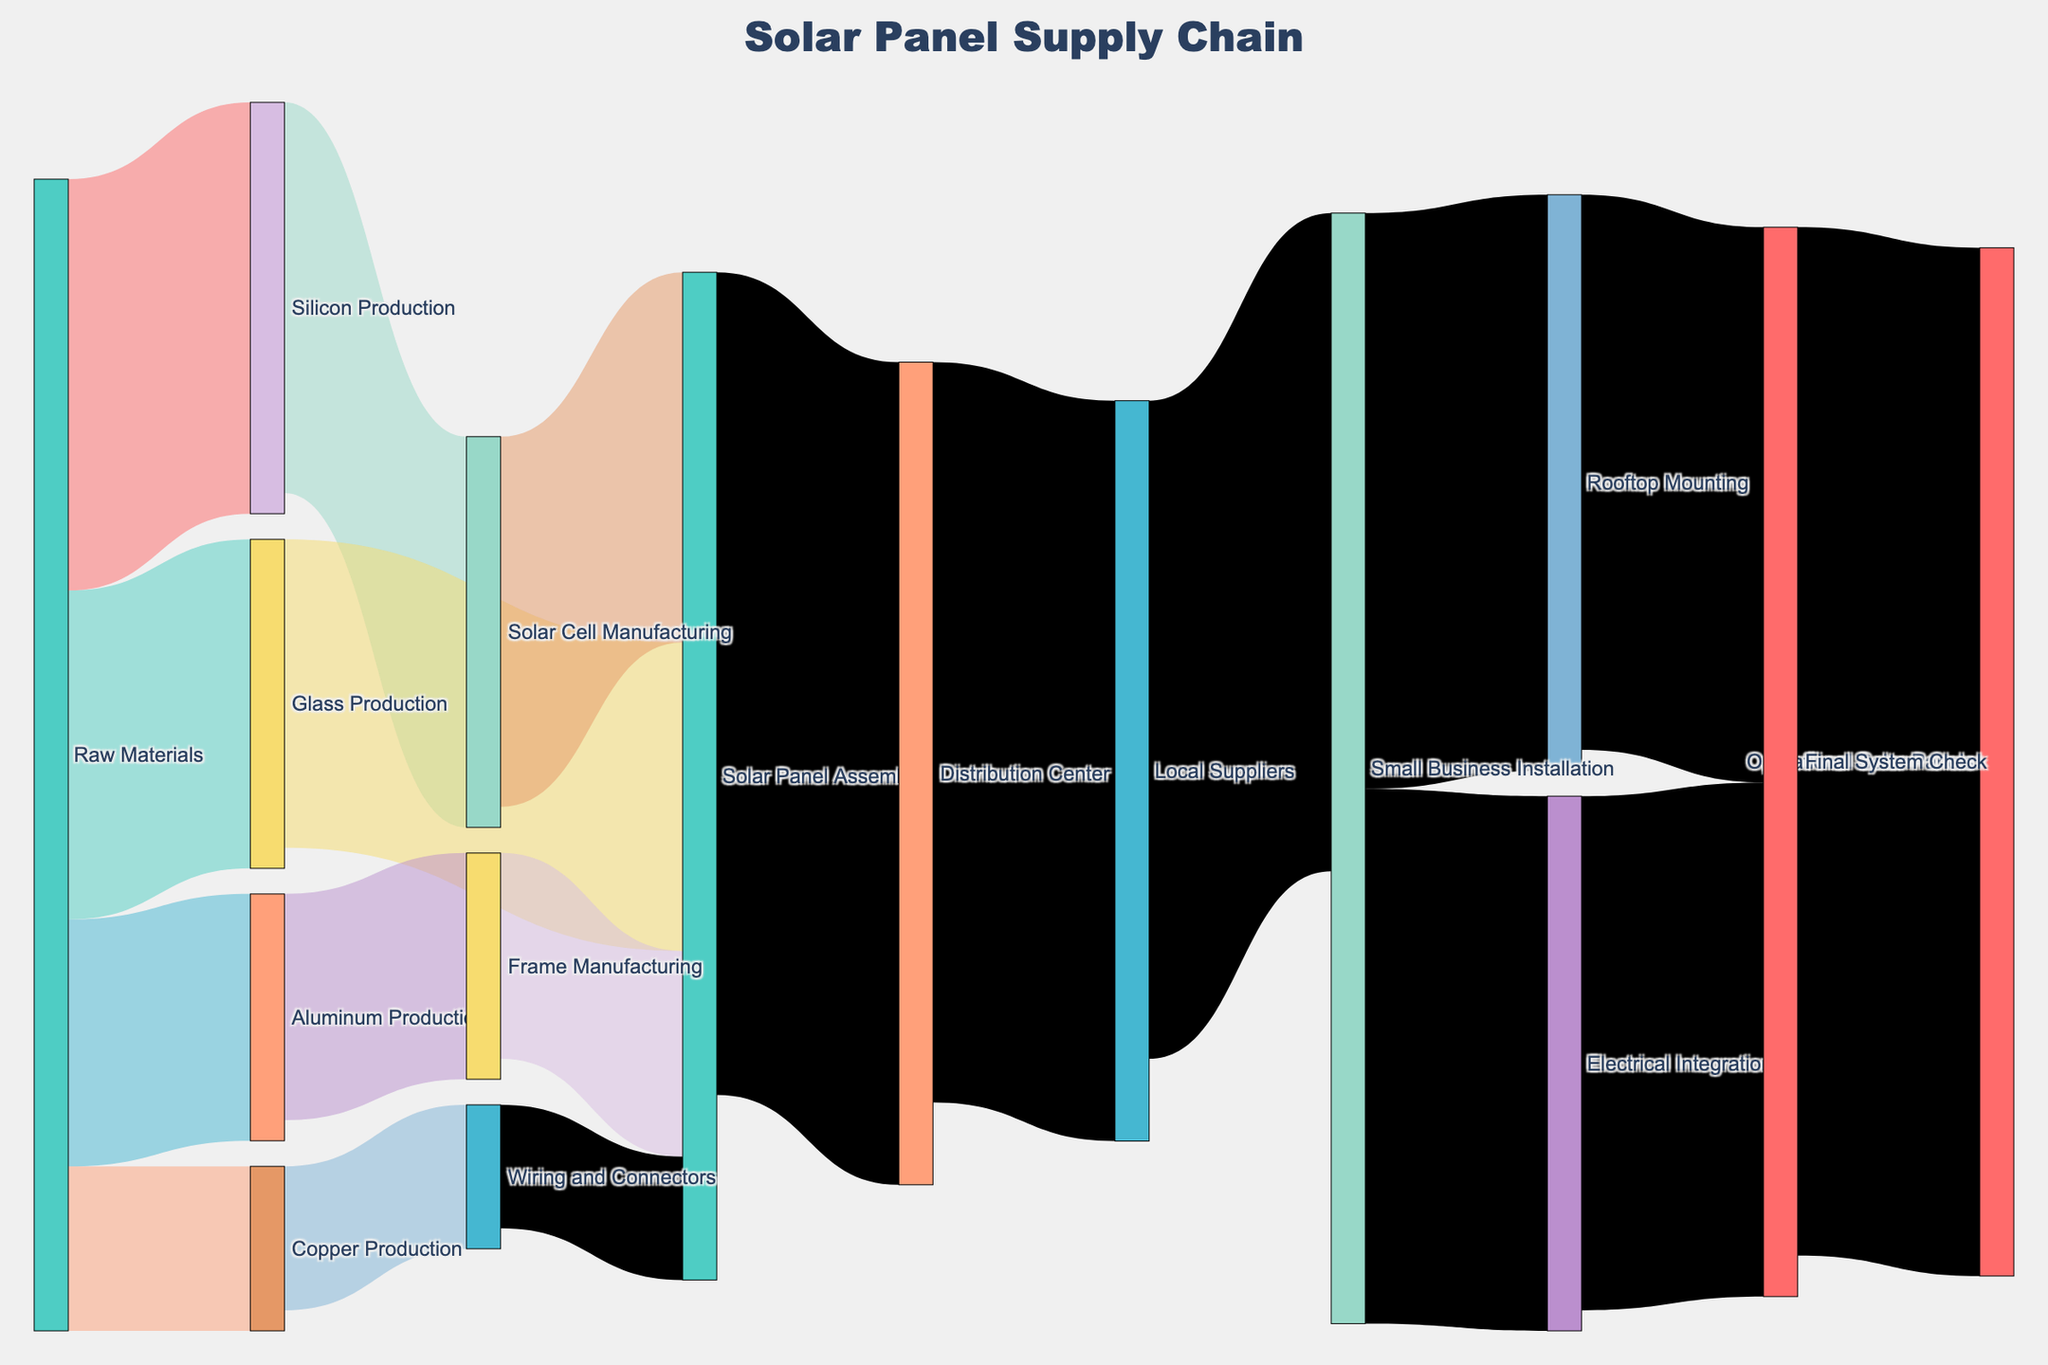What's the title of the diagram? The title is prominently displayed at the top of the diagram. It reads "Solar Panel Supply Chain."
Answer: Solar Panel Supply Chain What are the initial raw materials listed in the diagram? The initial raw materials are depicted as the first nodes and include Silicon Production, Glass Production, Aluminum Production, and Copper Production.
Answer: Silicon Production, Glass Production, Aluminum Production, Copper Production How many different supply chain stages are there from raw materials to operational solar panels? To count the stages, follow the flow from Raw Materials to Operational Solar Panels. The stages are Raw Materials, Intermediate Productions (like Silicon Production, Glass Production), Manufacturing steps (like Solar Cell Manufacturing, Solar Panel Assembly), Distribution steps (like Distribution Center, Local Suppliers), and Installation steps (like Small Business Installation, Final System Check).
Answer: Six stages What is the total value of solar panels assembled from raw materials? To find this, identify the flows into Solar Panel Assembly and sum up the values: 90 (from Solar Cell Manufacturing) + 75 (from Glass Production) + 50 (from Frame Manufacturing) + 30 (from Wiring and Connectors).
Answer: 245 Which supply chain stage receives the most value from the Distribution Center? Look at the flow values going from the Distribution Center. The values are 180 (to Local Suppliers).
Answer: Local Suppliers Compare the values of Small Business Installation between Rooftop Mounting and Electrical Integration. Check the flow values from Small Business Installation to both targets. Rooftop Mounting receives 140, while Electrical Integration receives 130.
Answer: Rooftop Mounting > Electrical Integration What is the combined value for the Final System Check stage? Sum the incoming values to Final System Check: 135 (from Rooftop Mounting) + 125 (from Electrical Integration).
Answer: 260 Which intermediate production stage has the highest output value, and what is that value? Compare the output values from Silicon Production (95), Glass Production (75), Aluminum Production (55), and Copper Production (35).
Answer: Solar Cell Manufacturing at 95 How is the distribution value from Local Suppliers to Small Business Installation depicted? The value shows how much is being transferred from Local Suppliers to Small Business Installation, indicated by 160.
Answer: 160 